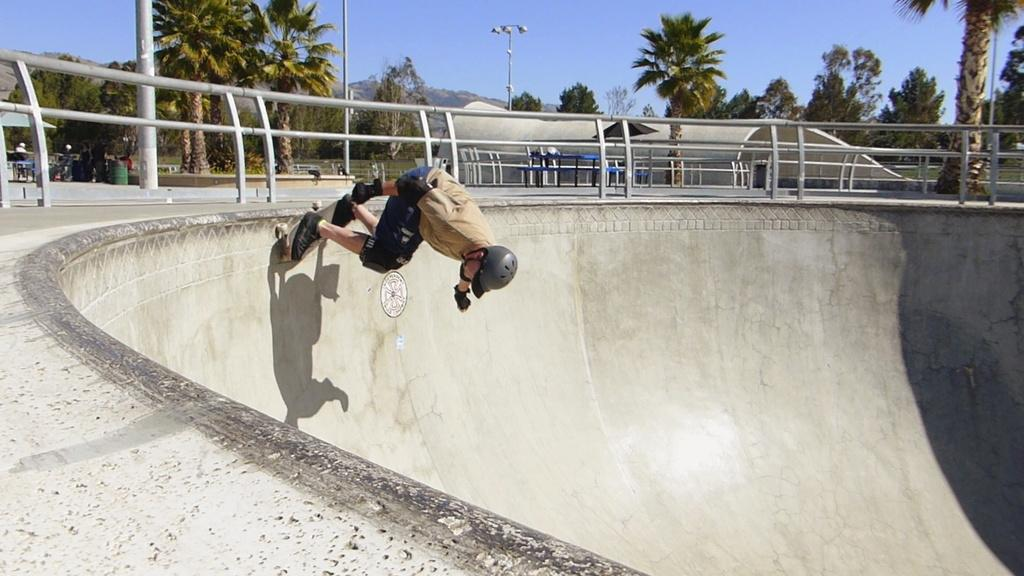Who is present in the image? There is a person in the image. What is the person wearing? The person is wearing a helmet. What activity is the person engaged in? The person is skating. What can be seen in the background of the image? There are trees, a bench, a streetlamp, and a group of people in the background of the image. What is visible at the top of the image? The sky is visible at the top of the image. What type of bottle is being passed around for approval in the image? There is no bottle or approval process depicted in the image; it features a person skating with a helmet. 